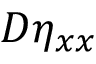<formula> <loc_0><loc_0><loc_500><loc_500>D \eta _ { x x }</formula> 